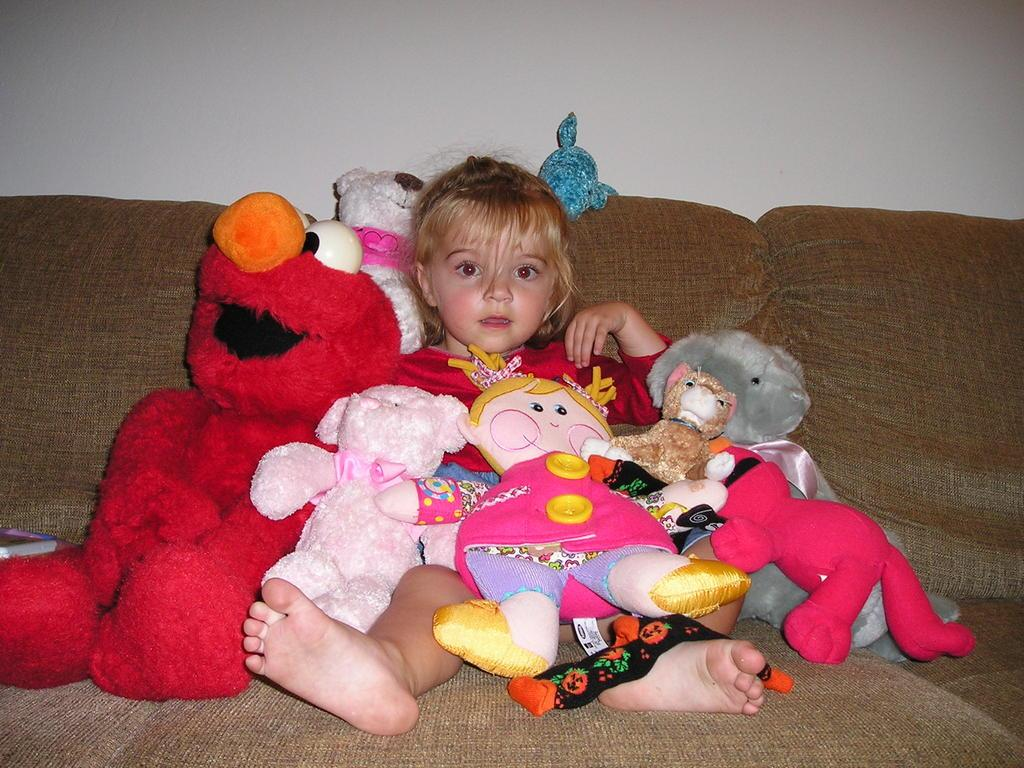Who is the main subject in the image? There is a small girl in the image. Where is the girl located in the image? The girl is in the center of the image. What is the girl sitting on? The girl is sitting on a sofa. What else can be seen around the girl? There are toys around the girl. What appliance is the girl using to measure the credit in the image? There is no appliance, measurement, or credit present in the image. 